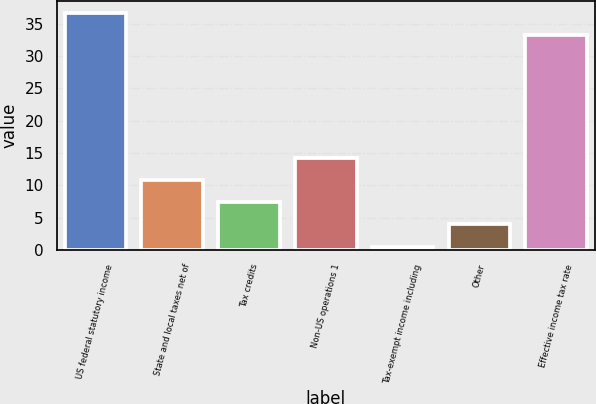Convert chart to OTSL. <chart><loc_0><loc_0><loc_500><loc_500><bar_chart><fcel>US federal statutory income<fcel>State and local taxes net of<fcel>Tax credits<fcel>Non-US operations 1<fcel>Tax-exempt income including<fcel>Other<fcel>Effective income tax rate<nl><fcel>36.75<fcel>10.85<fcel>7.4<fcel>14.3<fcel>0.5<fcel>3.95<fcel>33.3<nl></chart> 